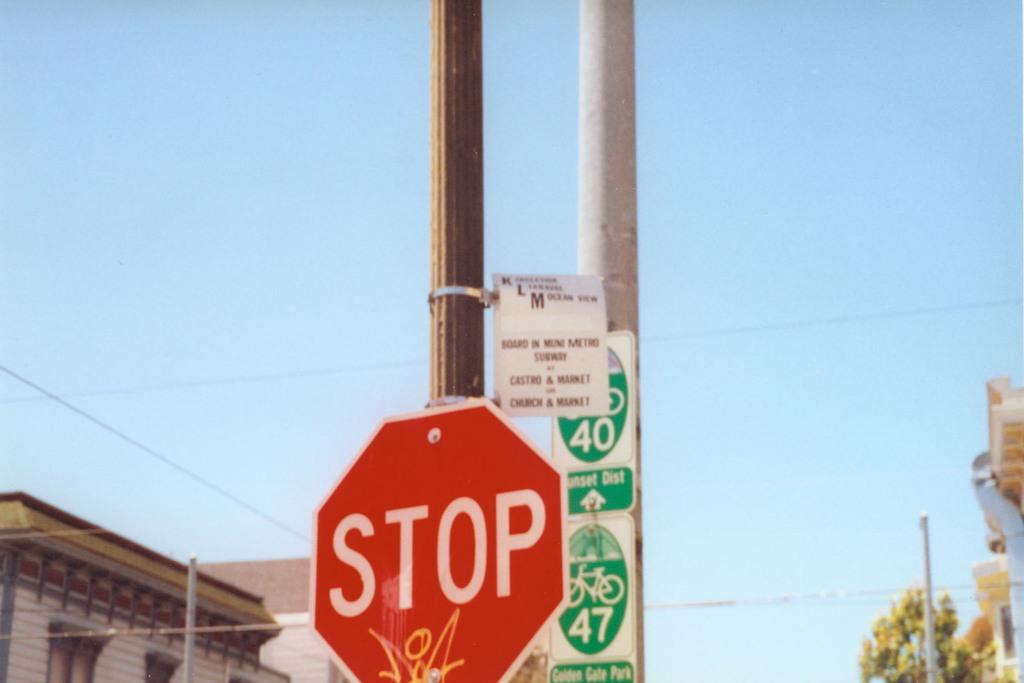<image>
Provide a brief description of the given image. a stop sign that is on a pole outside 